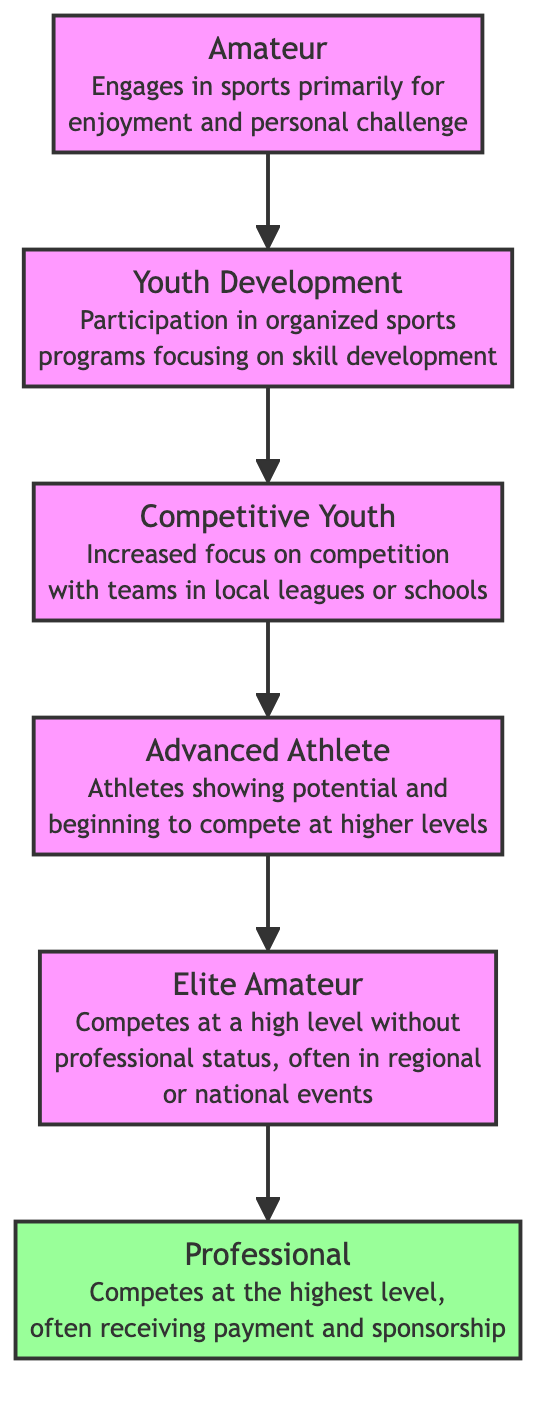What is the starting point in the athlete development stages? The starting point in the athlete development stages is represented by the node labeled "Amateur." This node describes athletes who engage in sports primarily for enjoyment and personal challenge.
Answer: Amateur How many nodes are present in the diagram? The diagram includes six nodes: Amateur, Youth Development, Competitive Youth, Advanced Athlete, Elite Amateur, and Professional.
Answer: 6 Which node directly follows "Competitive Youth" in the development process? Following "Competitive Youth," the next node in the progression is "Advanced Athlete." This indicates the sequential stages of athlete development.
Answer: Advanced Athlete What is the highest level an athlete can achieve in this diagram? The highest level represented in the diagram is the node labeled "Professional," indicating athletes who compete at the highest level with payment and sponsorship.
Answer: Professional How many directed edges are present in the diagram? The diagram has five directed edges connecting the nodes, denoting the flow from one development stage to the next.
Answer: 5 What is the relationship between "Advanced Athlete" and "Elite Amateur"? "Advanced Athlete" leads to "Elite Amateur," showing that an athlete can progress from showing potential to competing at a high level without professional status.
Answer: Leads to Which stage involves participation in organized sports programs? The stage involving participation in organized sports programs is "Youth Development," which focuses on skill development through organized activities.
Answer: Youth Development What type of athlete competes without professional status? The type of athlete who competes without professional status is known as an "Elite Amateur," as indicated in the diagram.
Answer: Elite Amateur Which two stages are adjacent to "Professional"? The "Professional" stage is adjacent to the "Elite Amateur" stage before it, indicating the last stage of development for athletes before reaching the professional level.
Answer: Elite Amateur What is the progression path from "Amateur" to "Professional"? The progression path from "Amateur" to "Professional" goes through the following stages: Amateur → Youth Development → Competitive Youth → Advanced Athlete → Elite Amateur → Professional. This shows the sequence of development.
Answer: Amateur, Youth Development, Competitive Youth, Advanced Athlete, Elite Amateur, Professional 